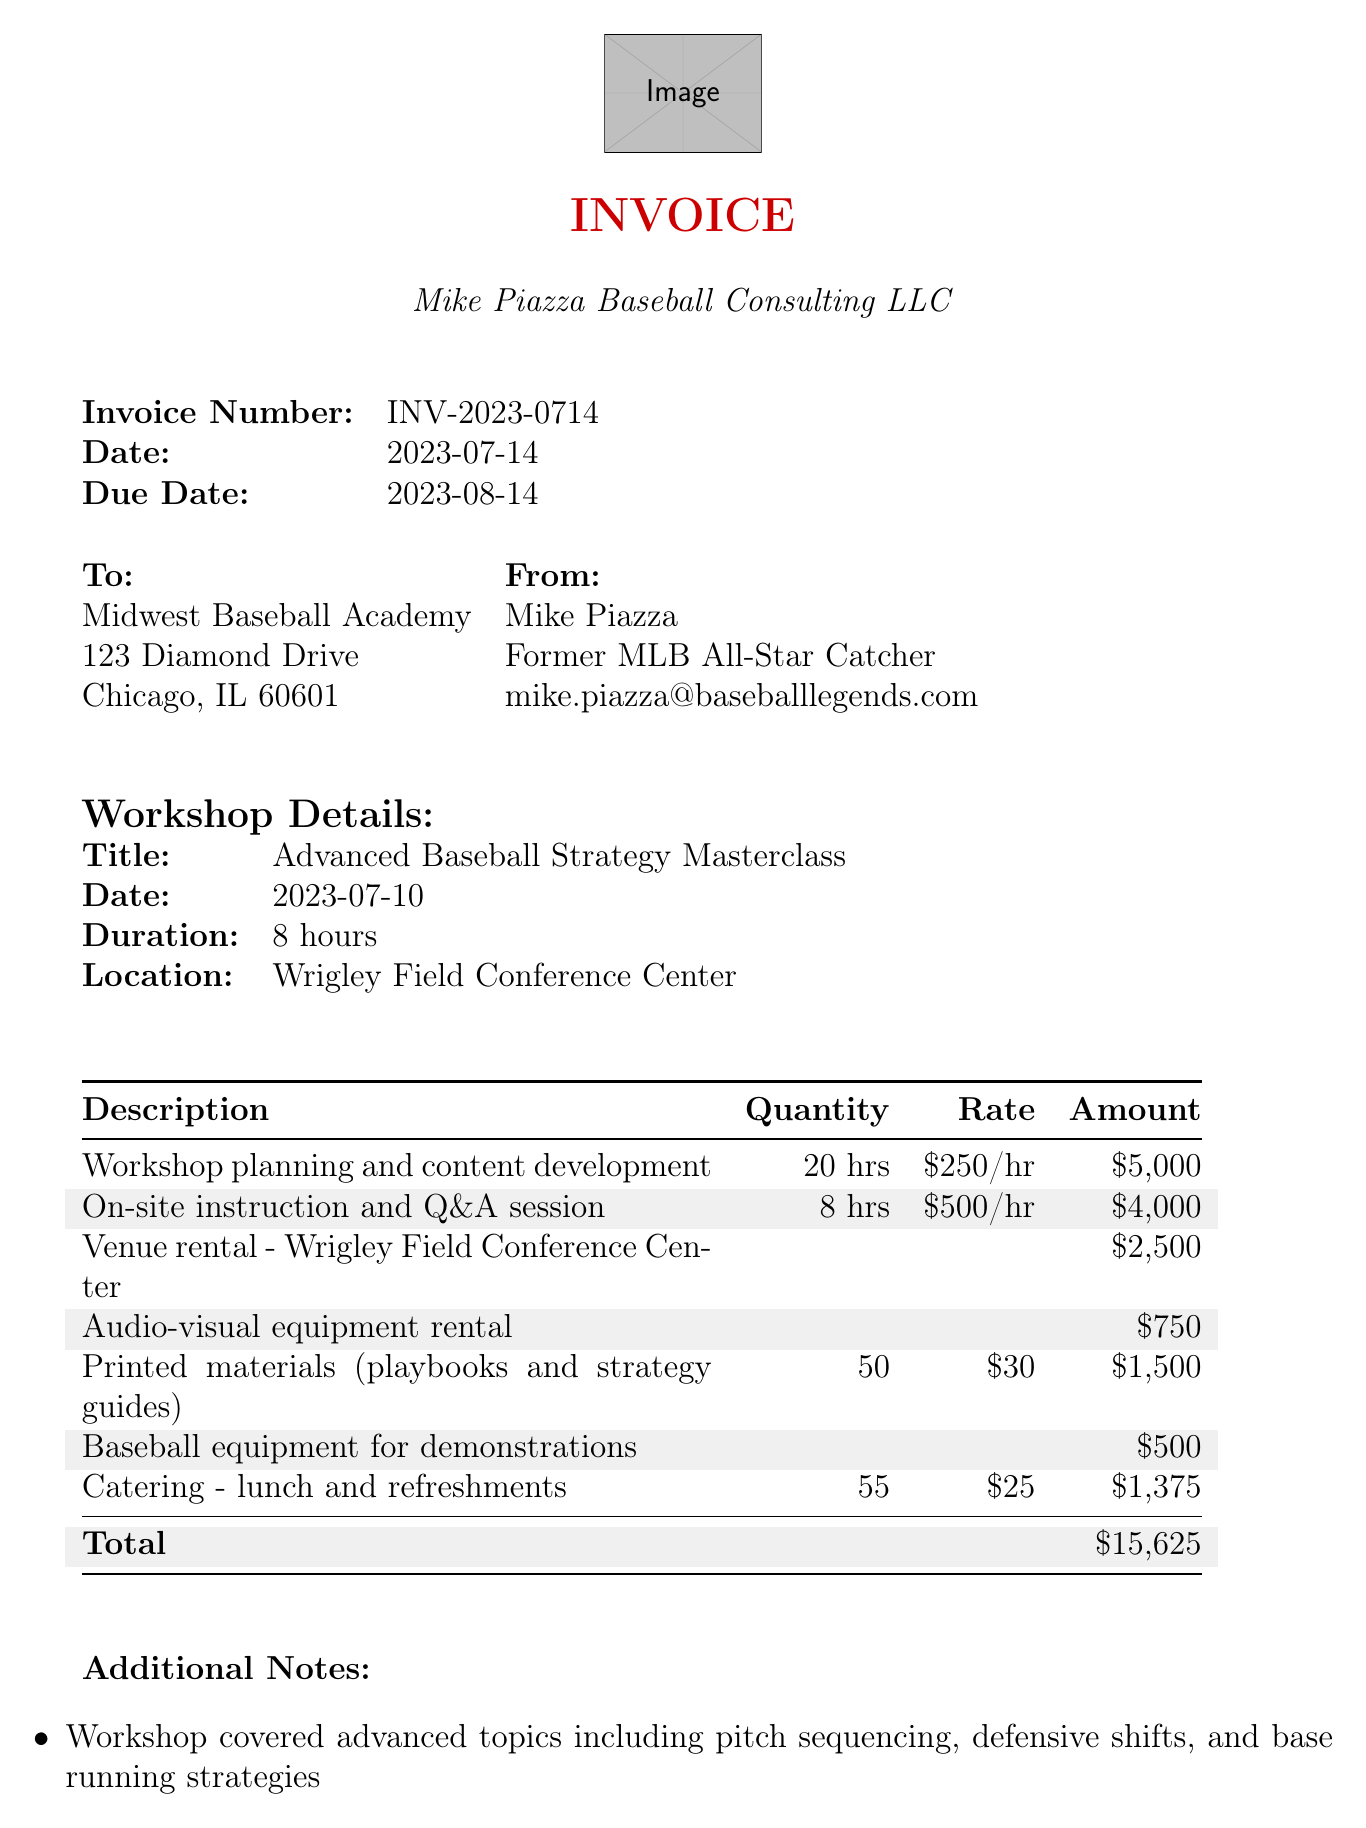What is the invoice number? The invoice number is specifically identified within the document for reference, which is INV-2023-0714.
Answer: INV-2023-0714 Who is the presenter? The presenter is mentioned along with their title, highlighting their expertise as "Mike Piazza, Former MLB All-Star Catcher."
Answer: Mike Piazza What is the total amount due? The total amount is calculated from all charges detailed in the line items of the invoice, which sums up to $15,625.
Answer: $15,625 What date is the workshop scheduled for? The document specifies the date of the workshop, which is an essential detail for the client, being July 10, 2023.
Answer: 2023-07-10 How many hours were dedicated to workshop planning? The hours for workshop planning are explicitly stated in the line items, which is 20 hours in total.
Answer: 20 hours What is the payment due date? The due date is outlined in the invoice details, indicating when payment should be made, set for August 14, 2023.
Answer: 2023-08-14 Which venue was rented for the workshop? The venue for the workshop is clearly mentioned and identified as "Wrigley Field Conference Center."
Answer: Wrigley Field Conference Center How many printed materials were provided? The invoice lists the quantity of printed materials involved, which totals 50 items.
Answer: 50 What is the purpose of the follow-up session scheduled for August 1, 2023? The follow-up session is indicated as an online Q&A, providing additional insight and clarification post-workshop.
Answer: Online Q&A session 